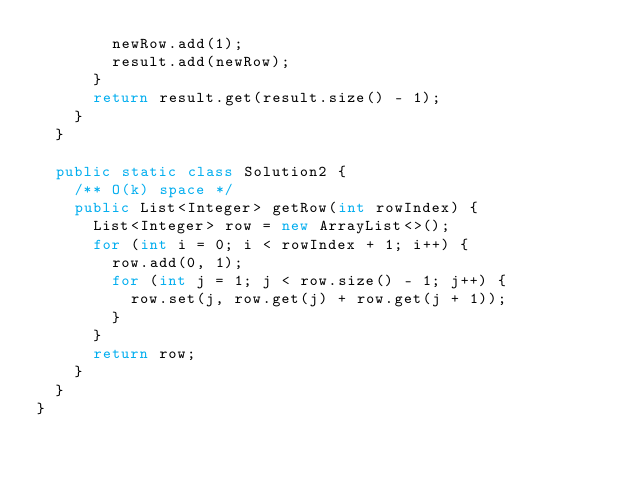Convert code to text. <code><loc_0><loc_0><loc_500><loc_500><_Java_>        newRow.add(1);
        result.add(newRow);
      }
      return result.get(result.size() - 1);
    }
  }

  public static class Solution2 {
    /** O(k) space */
    public List<Integer> getRow(int rowIndex) {
      List<Integer> row = new ArrayList<>();
      for (int i = 0; i < rowIndex + 1; i++) {
        row.add(0, 1);
        for (int j = 1; j < row.size() - 1; j++) {
          row.set(j, row.get(j) + row.get(j + 1));
        }
      }
      return row;
    }
  }
}
</code> 